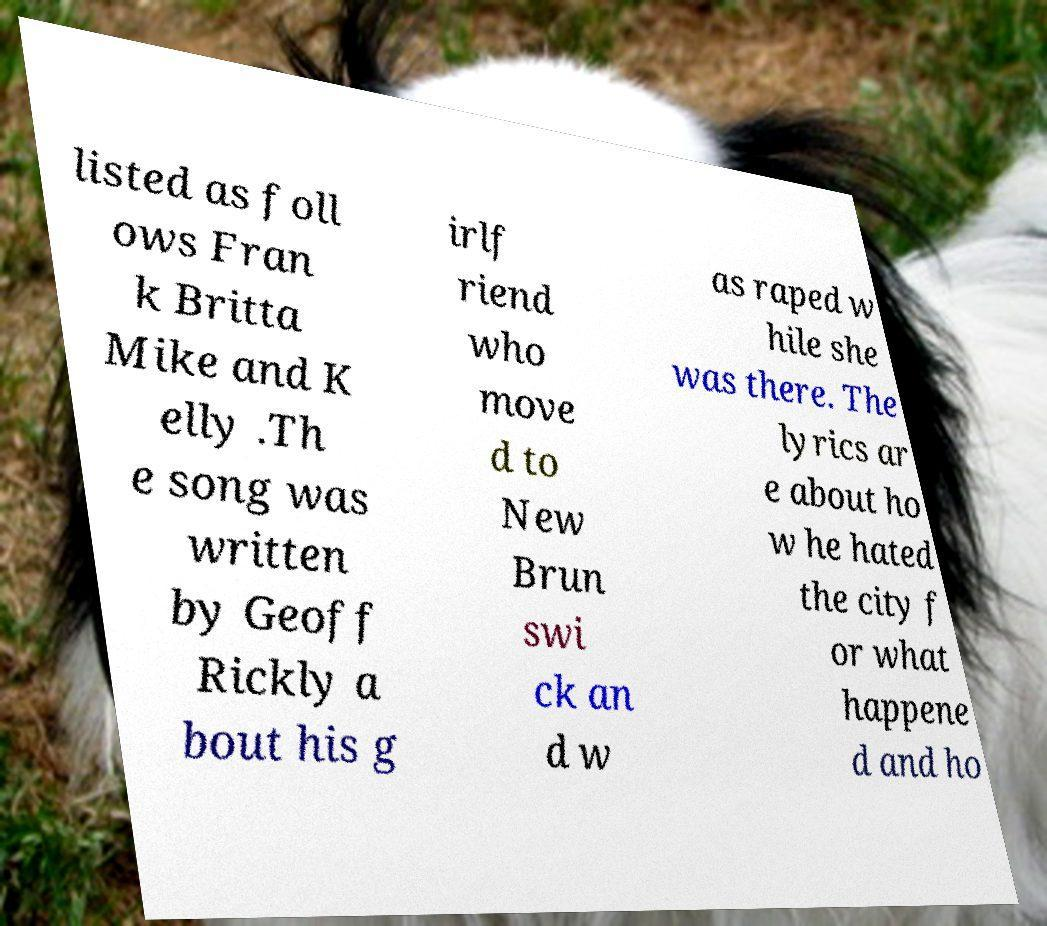Could you extract and type out the text from this image? listed as foll ows Fran k Britta Mike and K elly .Th e song was written by Geoff Rickly a bout his g irlf riend who move d to New Brun swi ck an d w as raped w hile she was there. The lyrics ar e about ho w he hated the city f or what happene d and ho 